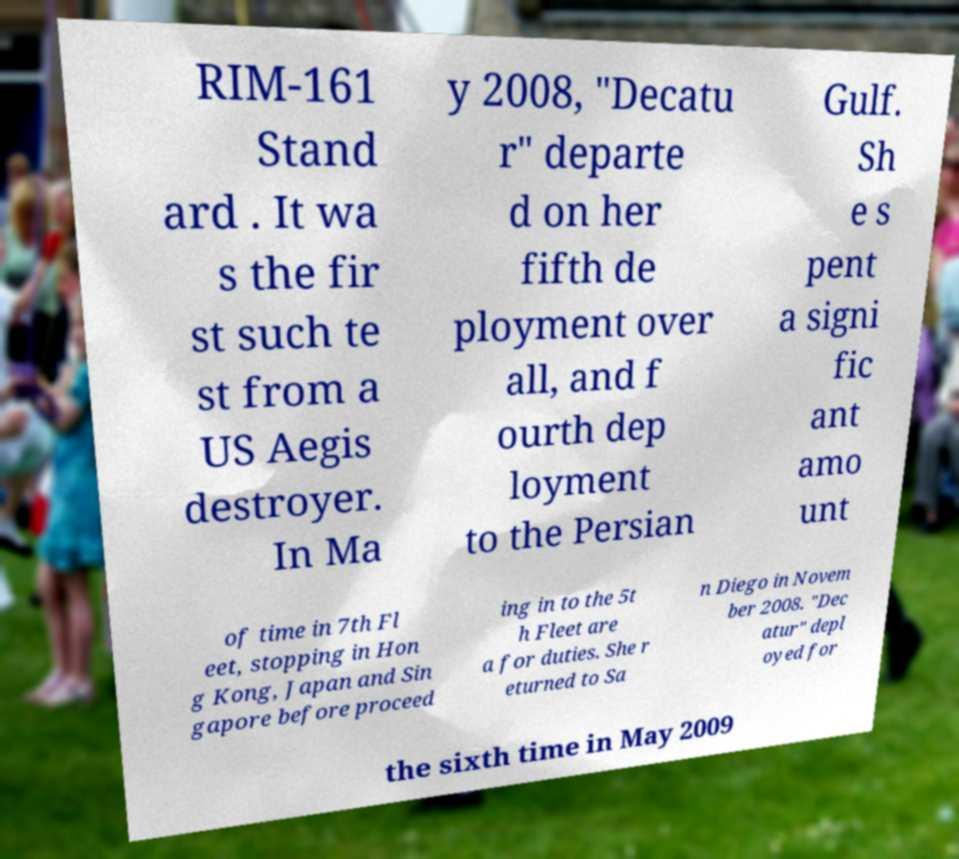Can you read and provide the text displayed in the image?This photo seems to have some interesting text. Can you extract and type it out for me? RIM-161 Stand ard . It wa s the fir st such te st from a US Aegis destroyer. In Ma y 2008, "Decatu r" departe d on her fifth de ployment over all, and f ourth dep loyment to the Persian Gulf. Sh e s pent a signi fic ant amo unt of time in 7th Fl eet, stopping in Hon g Kong, Japan and Sin gapore before proceed ing in to the 5t h Fleet are a for duties. She r eturned to Sa n Diego in Novem ber 2008. "Dec atur" depl oyed for the sixth time in May 2009 